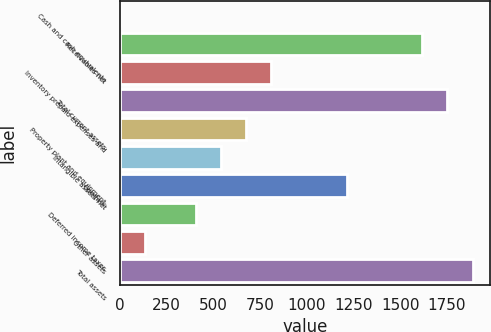Convert chart to OTSL. <chart><loc_0><loc_0><loc_500><loc_500><bar_chart><fcel>Cash and cash equivalents<fcel>Receivables net<fcel>Inventory prepaid expenses and<fcel>Total current assets<fcel>Property plant and equipment<fcel>Intangible assets net<fcel>Goodwill<fcel>Deferred income taxes<fcel>Other assets<fcel>Total assets<nl><fcel>1<fcel>1617.4<fcel>809.2<fcel>1752.1<fcel>674.5<fcel>539.8<fcel>1213.3<fcel>405.1<fcel>135.7<fcel>1886.8<nl></chart> 